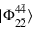<formula> <loc_0><loc_0><loc_500><loc_500>| \Phi _ { 2 \bar { 2 } } ^ { 4 \bar { 4 } } \rangle</formula> 